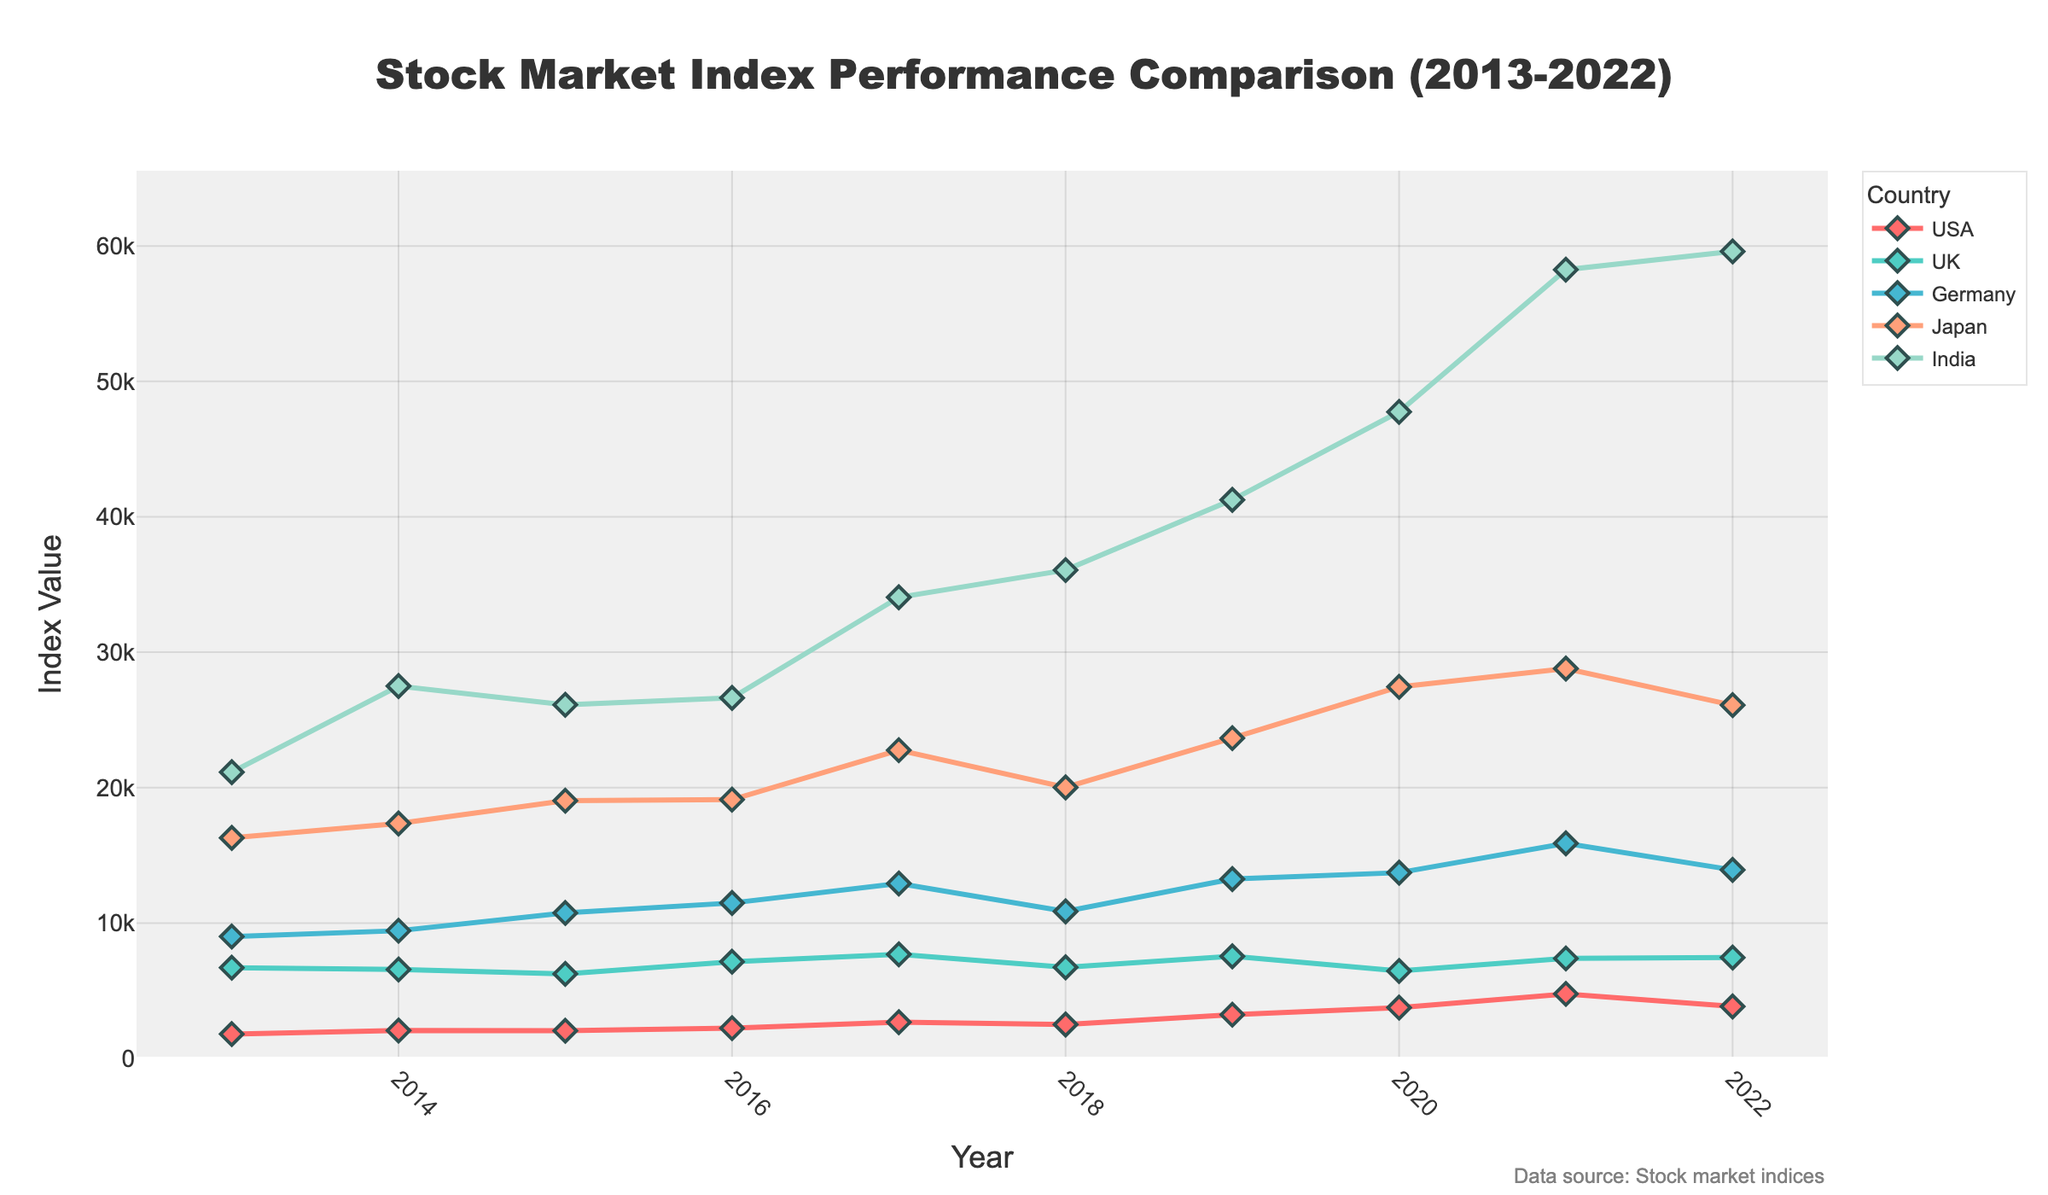What is the title of the plot? The title is usually displayed at the top of the plot. In this case, it reads "Stock Market Index Performance Comparison (2013-2022)"
Answer: Stock Market Index Performance Comparison (2013-2022) What does the x-axis represent? The x-axis, usually the horizontal axis in most plots, represents the "Year" in this time series plot.
Answer: Year Which country had the highest index value in 2022? Look for the year 2022 on the x-axis and identify the highest point among the countries in that year. India_Sensex has the highest value around 59601.84.
Answer: India How does the USA's S&P 500 index value change from 2013 to 2022? Track the line corresponding to the USA from 2013 to 2022; you will see that it starts around 1800.90 in 2013 and increases to about 3839.50 in 2022, with fluctuations in between.
Answer: It generally increases with fluctuations Which country's stock market index showed the most rapid increase between any two consecutive years? Compare the yearly differences for each country's indices and identify the largest increment. India_Sensex from 2020 (47751.33) to 2021 (58253.82) shows a significant rise.
Answer: India from 2020 to 2021 In which year did the UK FTSE 100 have its lowest index value? Look for the lowest point in the UK FTSE 100 line and trace it back to the x-axis. The lowest value is around 6242.32 in 2015.
Answer: 2015 What is the overall trend of the Germany DAX index from 2013 to 2022? Observe the trend line for Germany DAX from 2013 to 2022, noting whether it generally rises, falls, or remains stable. The Germany DAX generally shows an upward trend.
Answer: Upward Comparing 2020 and 2021, which country had the largest year-over-year change in index value? For each country, calculate the difference between their 2020 and 2021 values, then find the maximum difference. India had the largest change (58253.82 - 47751.33 = 10402.49).
Answer: India What year had the highest average index value across all countries? Calculate the average of all countries' index values for each year and identify the year with the highest average. 2021 has the highest average.
Answer: 2021 